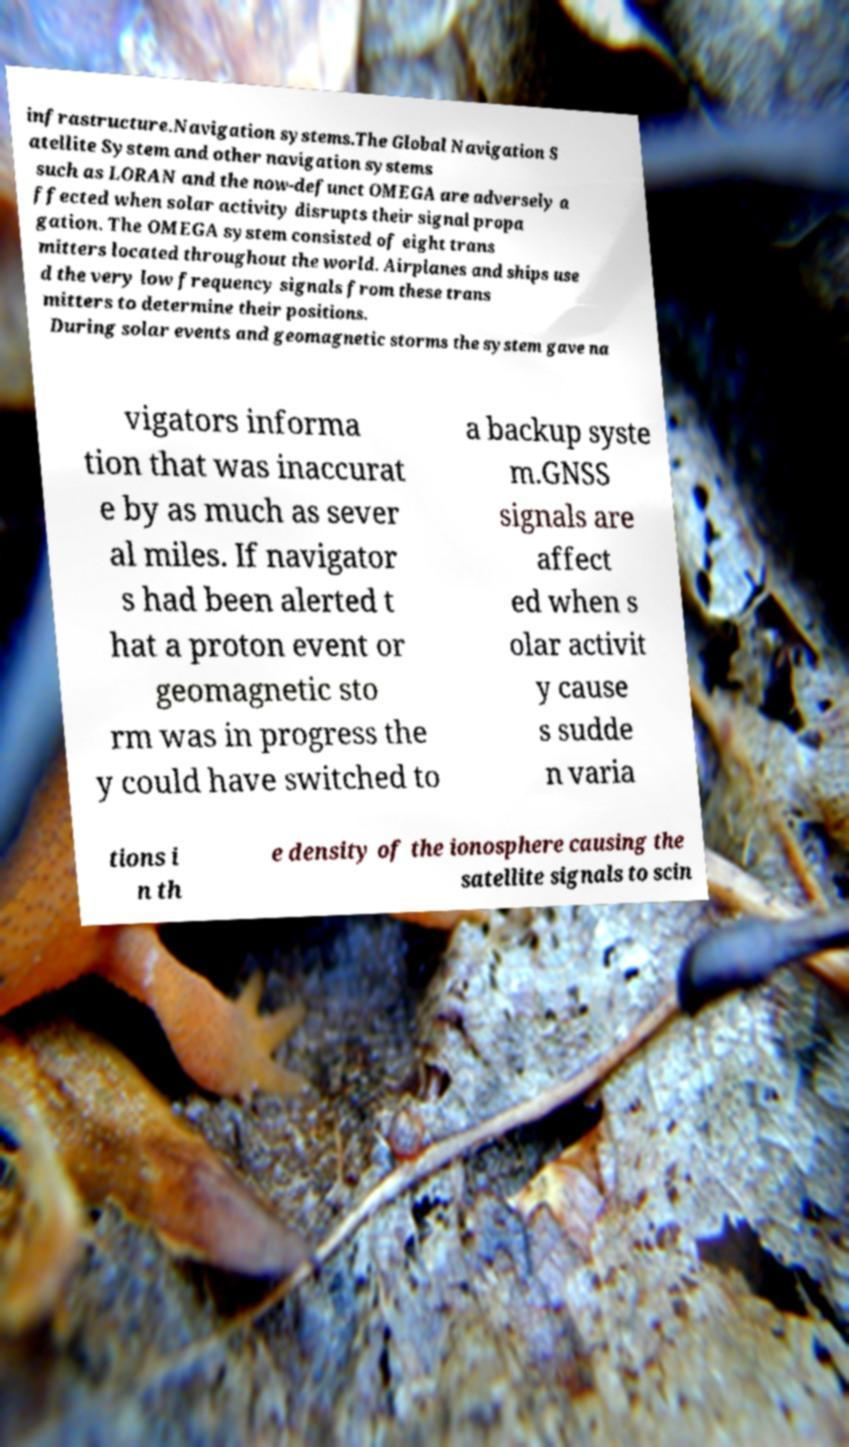I need the written content from this picture converted into text. Can you do that? infrastructure.Navigation systems.The Global Navigation S atellite System and other navigation systems such as LORAN and the now-defunct OMEGA are adversely a ffected when solar activity disrupts their signal propa gation. The OMEGA system consisted of eight trans mitters located throughout the world. Airplanes and ships use d the very low frequency signals from these trans mitters to determine their positions. During solar events and geomagnetic storms the system gave na vigators informa tion that was inaccurat e by as much as sever al miles. If navigator s had been alerted t hat a proton event or geomagnetic sto rm was in progress the y could have switched to a backup syste m.GNSS signals are affect ed when s olar activit y cause s sudde n varia tions i n th e density of the ionosphere causing the satellite signals to scin 